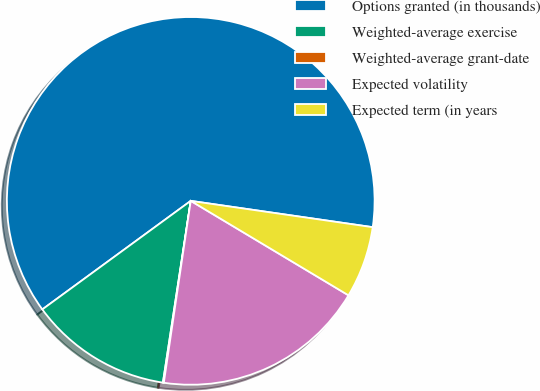Convert chart to OTSL. <chart><loc_0><loc_0><loc_500><loc_500><pie_chart><fcel>Options granted (in thousands)<fcel>Weighted-average exercise<fcel>Weighted-average grant-date<fcel>Expected volatility<fcel>Expected term (in years<nl><fcel>62.33%<fcel>12.53%<fcel>0.08%<fcel>18.75%<fcel>6.3%<nl></chart> 